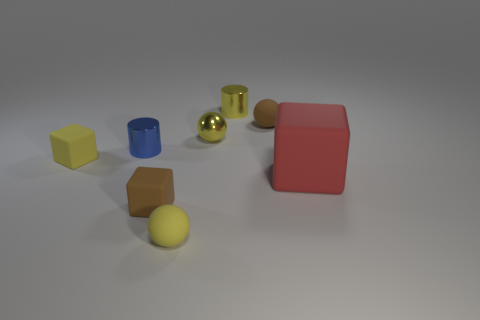How many yellow balls must be subtracted to get 1 yellow balls? 1 Subtract all metal balls. How many balls are left? 2 Add 1 metallic spheres. How many objects exist? 9 Subtract all brown cubes. How many cubes are left? 2 Subtract all cubes. How many objects are left? 5 Subtract 2 cylinders. How many cylinders are left? 0 Subtract all blue blocks. How many yellow balls are left? 2 Subtract all big blue metal things. Subtract all brown blocks. How many objects are left? 7 Add 5 shiny objects. How many shiny objects are left? 8 Add 8 yellow shiny cylinders. How many yellow shiny cylinders exist? 9 